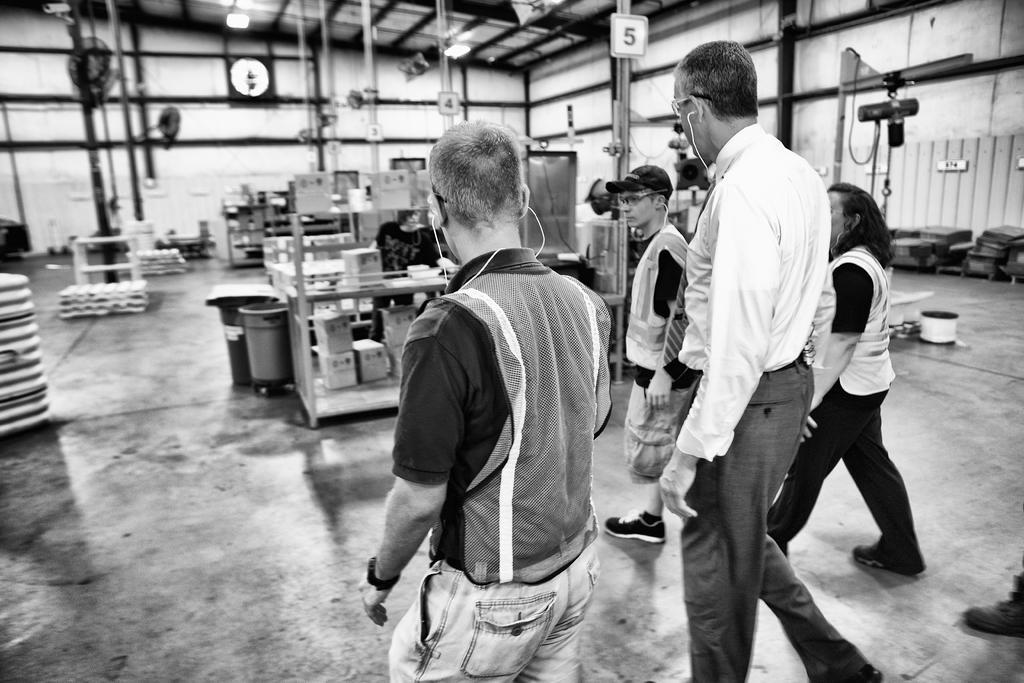How would you summarize this image in a sentence or two? In this picture we can see some people are walking, in the background there are some metal rods and boards, on the left side we can see dustbins, there are some cardboard boxes in the middle, it is a black and white image, we can also see a wall in the background, there are lights at the top of the picture. 